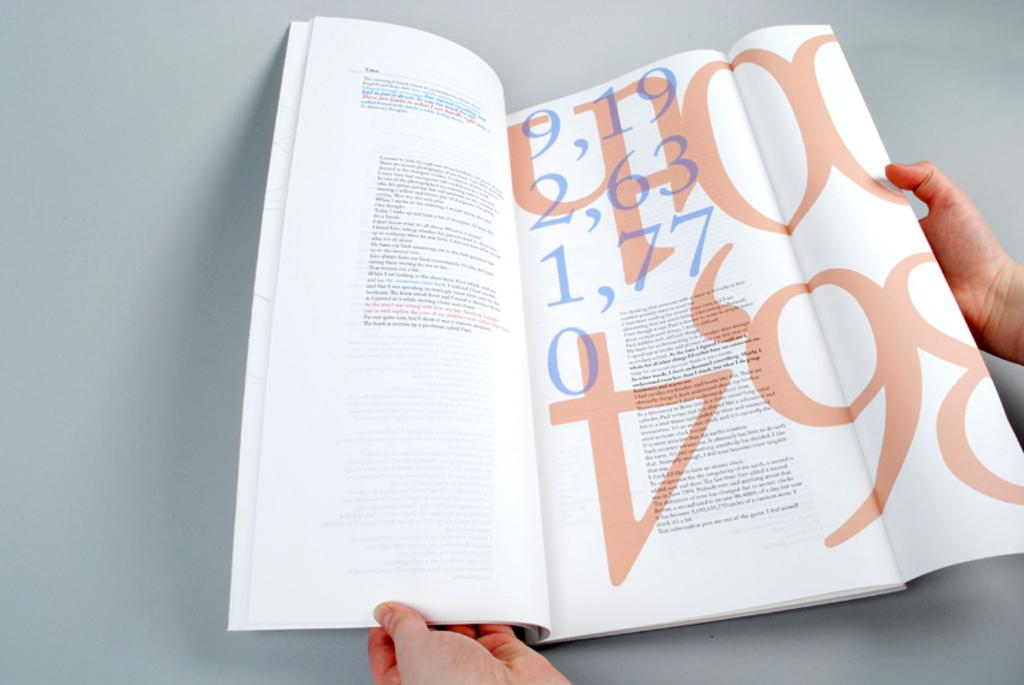<image>
Give a short and clear explanation of the subsequent image. A book that is opened to a page talking about time. 